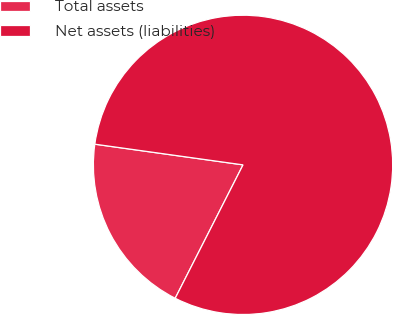<chart> <loc_0><loc_0><loc_500><loc_500><pie_chart><fcel>Total assets<fcel>Net assets (liabilities)<nl><fcel>19.72%<fcel>80.28%<nl></chart> 